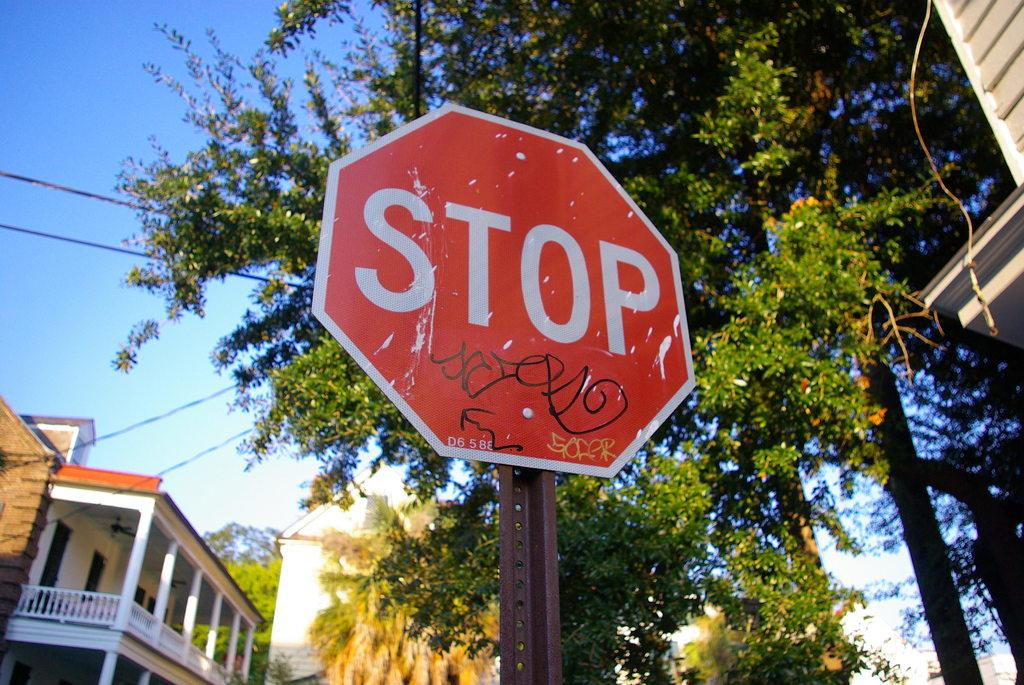What is the main object in the image? There is a sign board in the image. How is the sign board positioned in the image? The sign board is attached to a pole. What can be seen in the background of the image? There are buildings, trees, wires, and the sky visible in the background of the image. What type of oatmeal is being served at the restaurant in the image? There is no restaurant or oatmeal present in the image; it features a sign board attached to a pole with a background of buildings, trees, wires, and the sky. 